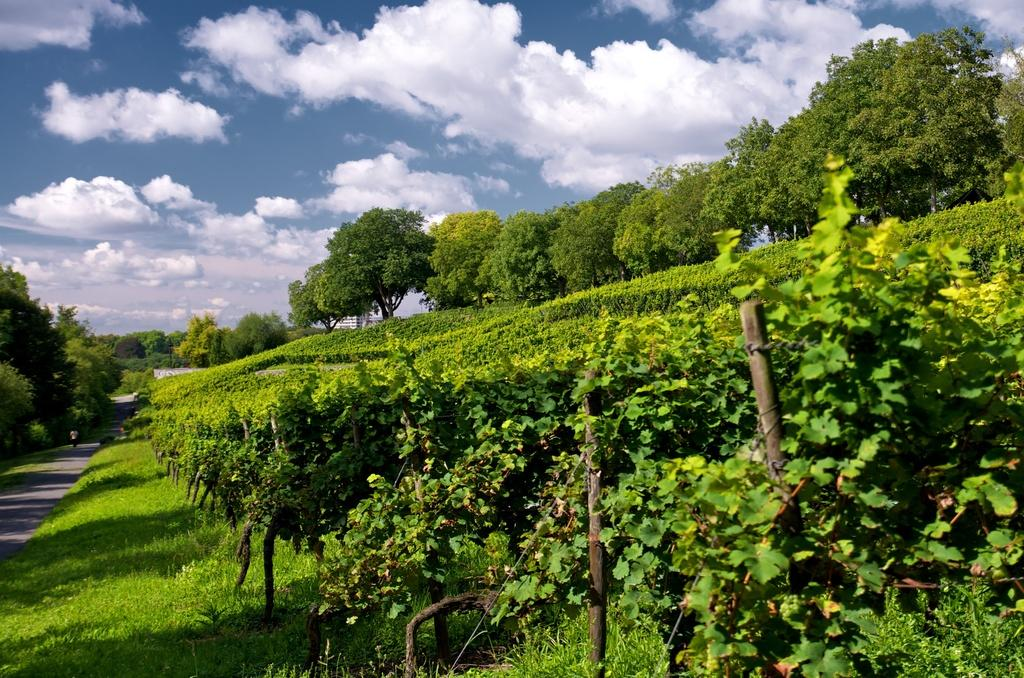What is the person in the image doing? There is a person walking on the road in the image. What can be seen in the background of the image? There are many trees and plants in the image, and the grassy land is also visible. How is the sky depicted in the image? The sky is blue and cloudy in the image. What time is displayed on the clock in the image? There is no clock present in the image. What relation does the person walking on the road have with the plants in the image? The provided facts do not mention any relation between the person and the plants; they are simply elements in the same image. 